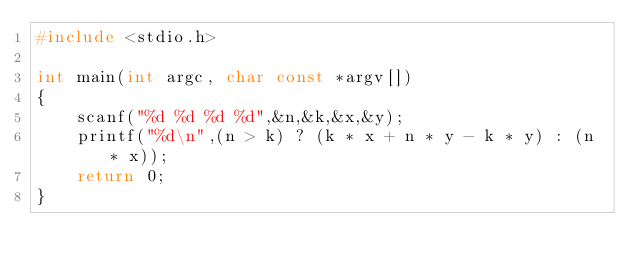<code> <loc_0><loc_0><loc_500><loc_500><_C_>#include <stdio.h>

int main(int argc, char const *argv[])
{
	scanf("%d %d %d %d",&n,&k,&x,&y);
	printf("%d\n",(n > k) ? (k * x + n * y - k * y) : (n * x));
	return 0;
}
</code> 